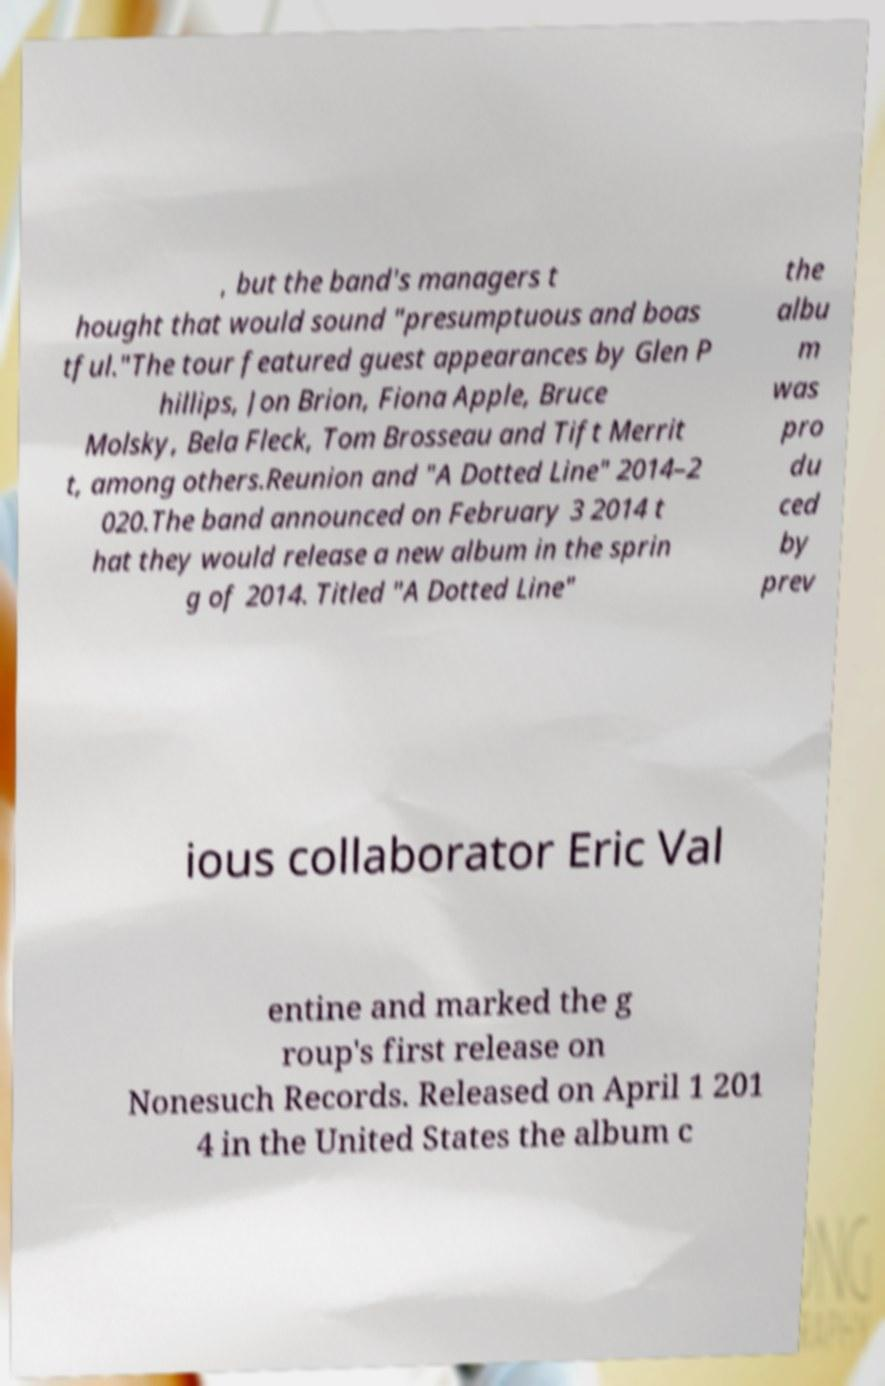For documentation purposes, I need the text within this image transcribed. Could you provide that? , but the band's managers t hought that would sound "presumptuous and boas tful."The tour featured guest appearances by Glen P hillips, Jon Brion, Fiona Apple, Bruce Molsky, Bela Fleck, Tom Brosseau and Tift Merrit t, among others.Reunion and "A Dotted Line" 2014–2 020.The band announced on February 3 2014 t hat they would release a new album in the sprin g of 2014. Titled "A Dotted Line" the albu m was pro du ced by prev ious collaborator Eric Val entine and marked the g roup's first release on Nonesuch Records. Released on April 1 201 4 in the United States the album c 